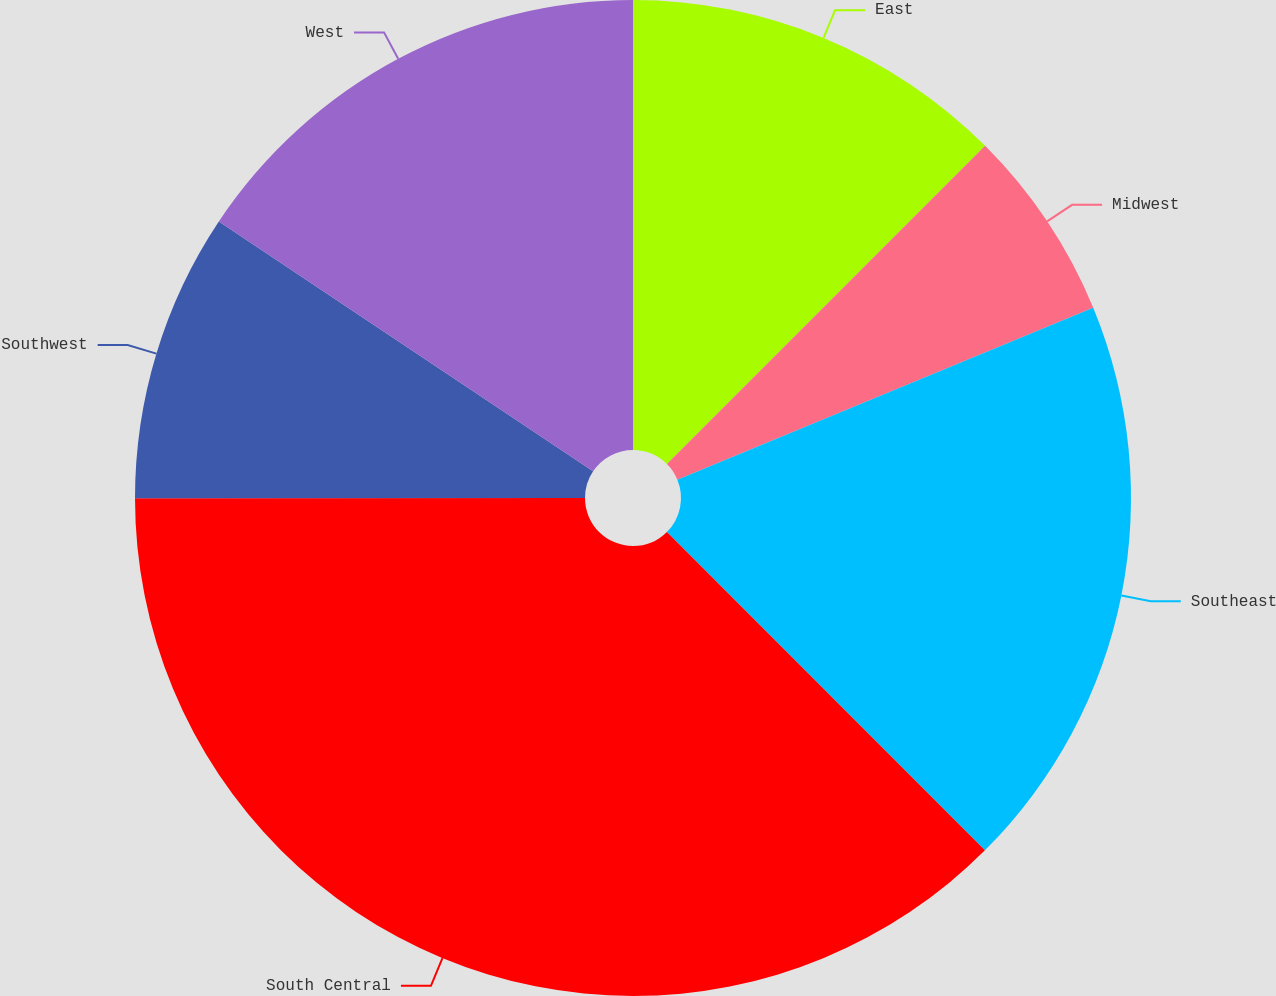<chart> <loc_0><loc_0><loc_500><loc_500><pie_chart><fcel>East<fcel>Midwest<fcel>Southeast<fcel>South Central<fcel>Southwest<fcel>West<nl><fcel>12.5%<fcel>6.26%<fcel>18.75%<fcel>37.48%<fcel>9.38%<fcel>15.63%<nl></chart> 